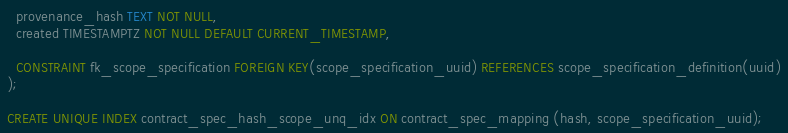Convert code to text. <code><loc_0><loc_0><loc_500><loc_500><_SQL_>  provenance_hash TEXT NOT NULL,
  created TIMESTAMPTZ NOT NULL DEFAULT CURRENT_TIMESTAMP,

  CONSTRAINT fk_scope_specification FOREIGN KEY(scope_specification_uuid) REFERENCES scope_specification_definition(uuid)
);

CREATE UNIQUE INDEX contract_spec_hash_scope_unq_idx ON contract_spec_mapping (hash, scope_specification_uuid);
</code> 